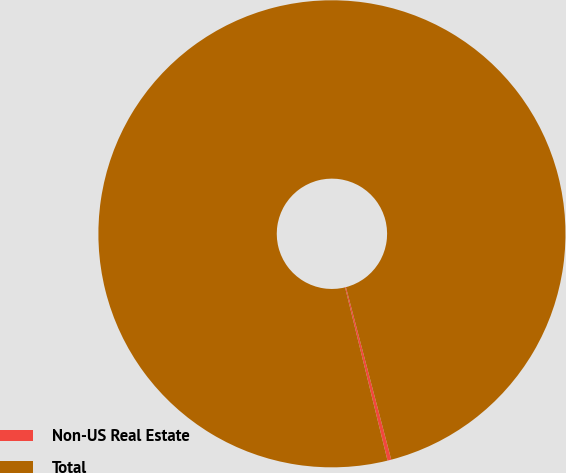Convert chart. <chart><loc_0><loc_0><loc_500><loc_500><pie_chart><fcel>Non-US Real Estate<fcel>Total<nl><fcel>0.26%<fcel>99.74%<nl></chart> 